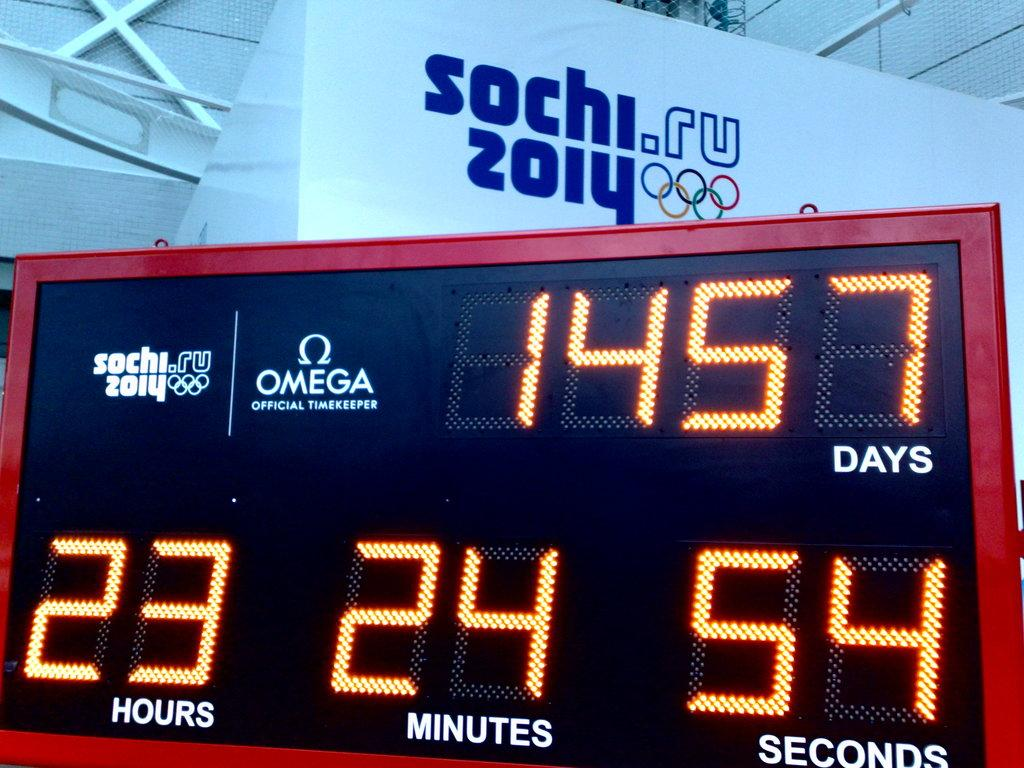<image>
Render a clear and concise summary of the photo. A timer counting days in relation to the 2014 Sochi Olympics. 